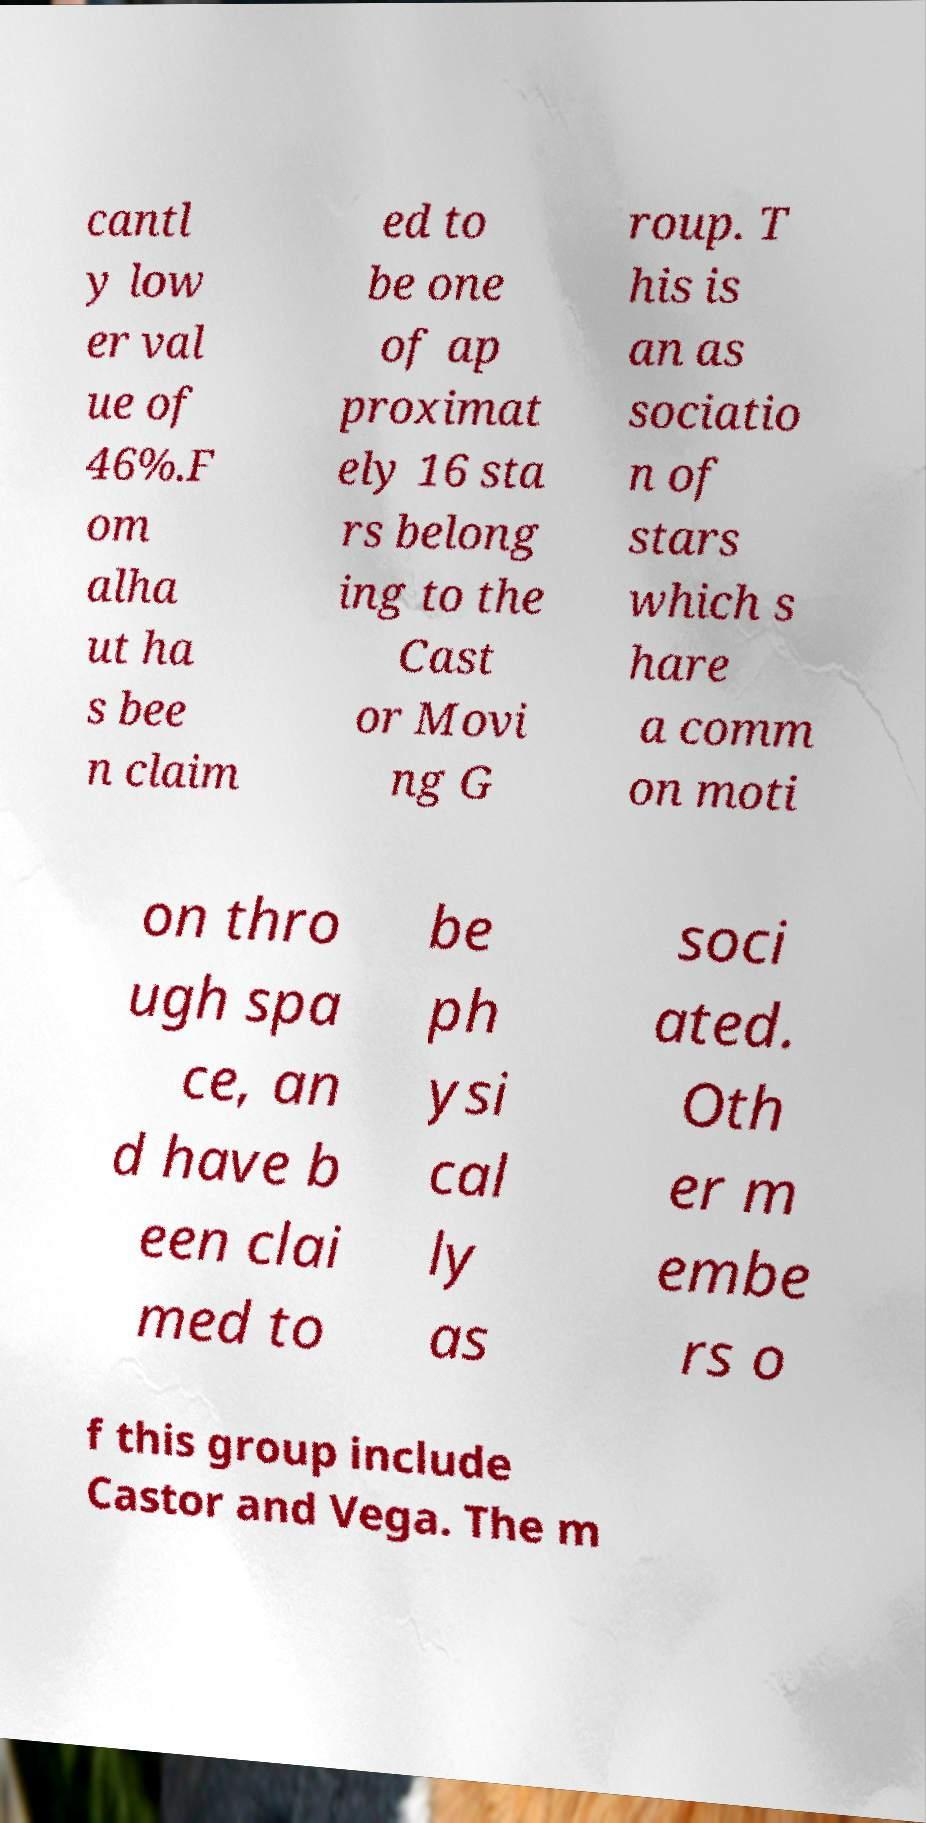Please identify and transcribe the text found in this image. cantl y low er val ue of 46%.F om alha ut ha s bee n claim ed to be one of ap proximat ely 16 sta rs belong ing to the Cast or Movi ng G roup. T his is an as sociatio n of stars which s hare a comm on moti on thro ugh spa ce, an d have b een clai med to be ph ysi cal ly as soci ated. Oth er m embe rs o f this group include Castor and Vega. The m 